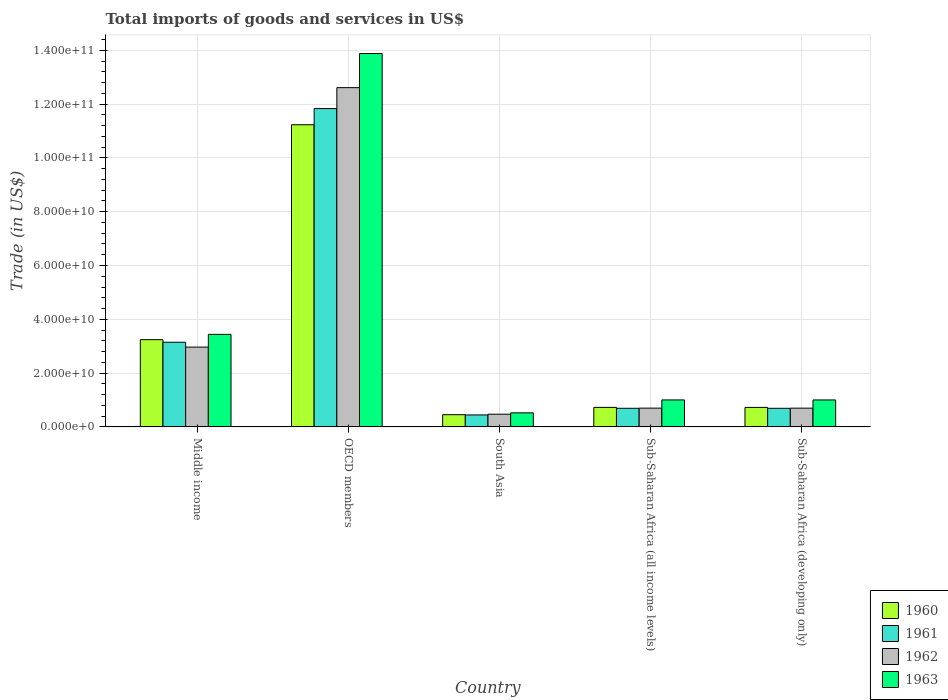How many bars are there on the 2nd tick from the left?
Keep it short and to the point. 4. What is the label of the 2nd group of bars from the left?
Provide a short and direct response. OECD members. In how many cases, is the number of bars for a given country not equal to the number of legend labels?
Your response must be concise. 0. What is the total imports of goods and services in 1963 in Middle income?
Give a very brief answer. 3.44e+1. Across all countries, what is the maximum total imports of goods and services in 1963?
Make the answer very short. 1.39e+11. Across all countries, what is the minimum total imports of goods and services in 1960?
Offer a very short reply. 4.53e+09. What is the total total imports of goods and services in 1963 in the graph?
Your answer should be very brief. 1.98e+11. What is the difference between the total imports of goods and services in 1960 in OECD members and that in South Asia?
Offer a very short reply. 1.08e+11. What is the difference between the total imports of goods and services in 1963 in South Asia and the total imports of goods and services in 1960 in Middle income?
Your response must be concise. -2.72e+1. What is the average total imports of goods and services in 1961 per country?
Provide a short and direct response. 3.36e+1. What is the difference between the total imports of goods and services of/in 1960 and total imports of goods and services of/in 1962 in OECD members?
Your response must be concise. -1.38e+1. What is the ratio of the total imports of goods and services in 1961 in OECD members to that in Sub-Saharan Africa (developing only)?
Provide a short and direct response. 17.14. What is the difference between the highest and the second highest total imports of goods and services in 1961?
Offer a terse response. -8.69e+1. What is the difference between the highest and the lowest total imports of goods and services in 1961?
Make the answer very short. 1.14e+11. Is the sum of the total imports of goods and services in 1960 in OECD members and Sub-Saharan Africa (developing only) greater than the maximum total imports of goods and services in 1961 across all countries?
Your answer should be very brief. Yes. What does the 4th bar from the left in Sub-Saharan Africa (all income levels) represents?
Provide a short and direct response. 1963. Is it the case that in every country, the sum of the total imports of goods and services in 1962 and total imports of goods and services in 1960 is greater than the total imports of goods and services in 1963?
Ensure brevity in your answer.  Yes. How many countries are there in the graph?
Provide a succinct answer. 5. What is the difference between two consecutive major ticks on the Y-axis?
Your answer should be compact. 2.00e+1. Are the values on the major ticks of Y-axis written in scientific E-notation?
Give a very brief answer. Yes. Where does the legend appear in the graph?
Ensure brevity in your answer.  Bottom right. How many legend labels are there?
Provide a short and direct response. 4. What is the title of the graph?
Make the answer very short. Total imports of goods and services in US$. Does "2003" appear as one of the legend labels in the graph?
Provide a short and direct response. No. What is the label or title of the Y-axis?
Your response must be concise. Trade (in US$). What is the Trade (in US$) in 1960 in Middle income?
Give a very brief answer. 3.24e+1. What is the Trade (in US$) in 1961 in Middle income?
Provide a short and direct response. 3.15e+1. What is the Trade (in US$) of 1962 in Middle income?
Offer a very short reply. 2.97e+1. What is the Trade (in US$) in 1963 in Middle income?
Provide a short and direct response. 3.44e+1. What is the Trade (in US$) in 1960 in OECD members?
Your answer should be compact. 1.12e+11. What is the Trade (in US$) of 1961 in OECD members?
Keep it short and to the point. 1.18e+11. What is the Trade (in US$) in 1962 in OECD members?
Offer a terse response. 1.26e+11. What is the Trade (in US$) of 1963 in OECD members?
Ensure brevity in your answer.  1.39e+11. What is the Trade (in US$) in 1960 in South Asia?
Your answer should be compact. 4.53e+09. What is the Trade (in US$) in 1961 in South Asia?
Your response must be concise. 4.43e+09. What is the Trade (in US$) in 1962 in South Asia?
Your answer should be compact. 4.71e+09. What is the Trade (in US$) of 1963 in South Asia?
Offer a terse response. 5.21e+09. What is the Trade (in US$) in 1960 in Sub-Saharan Africa (all income levels)?
Keep it short and to the point. 7.25e+09. What is the Trade (in US$) in 1961 in Sub-Saharan Africa (all income levels)?
Provide a short and direct response. 6.91e+09. What is the Trade (in US$) in 1962 in Sub-Saharan Africa (all income levels)?
Keep it short and to the point. 6.97e+09. What is the Trade (in US$) of 1963 in Sub-Saharan Africa (all income levels)?
Offer a very short reply. 1.00e+1. What is the Trade (in US$) of 1960 in Sub-Saharan Africa (developing only)?
Offer a very short reply. 7.24e+09. What is the Trade (in US$) of 1961 in Sub-Saharan Africa (developing only)?
Offer a terse response. 6.90e+09. What is the Trade (in US$) in 1962 in Sub-Saharan Africa (developing only)?
Your answer should be very brief. 6.96e+09. What is the Trade (in US$) in 1963 in Sub-Saharan Africa (developing only)?
Your answer should be very brief. 1.00e+1. Across all countries, what is the maximum Trade (in US$) of 1960?
Your answer should be compact. 1.12e+11. Across all countries, what is the maximum Trade (in US$) in 1961?
Keep it short and to the point. 1.18e+11. Across all countries, what is the maximum Trade (in US$) of 1962?
Your answer should be compact. 1.26e+11. Across all countries, what is the maximum Trade (in US$) of 1963?
Your answer should be very brief. 1.39e+11. Across all countries, what is the minimum Trade (in US$) in 1960?
Provide a succinct answer. 4.53e+09. Across all countries, what is the minimum Trade (in US$) in 1961?
Ensure brevity in your answer.  4.43e+09. Across all countries, what is the minimum Trade (in US$) in 1962?
Ensure brevity in your answer.  4.71e+09. Across all countries, what is the minimum Trade (in US$) in 1963?
Provide a succinct answer. 5.21e+09. What is the total Trade (in US$) of 1960 in the graph?
Offer a terse response. 1.64e+11. What is the total Trade (in US$) in 1961 in the graph?
Your answer should be very brief. 1.68e+11. What is the total Trade (in US$) in 1962 in the graph?
Your answer should be compact. 1.74e+11. What is the total Trade (in US$) in 1963 in the graph?
Keep it short and to the point. 1.98e+11. What is the difference between the Trade (in US$) of 1960 in Middle income and that in OECD members?
Ensure brevity in your answer.  -7.99e+1. What is the difference between the Trade (in US$) in 1961 in Middle income and that in OECD members?
Provide a short and direct response. -8.69e+1. What is the difference between the Trade (in US$) of 1962 in Middle income and that in OECD members?
Provide a short and direct response. -9.65e+1. What is the difference between the Trade (in US$) in 1963 in Middle income and that in OECD members?
Your answer should be compact. -1.04e+11. What is the difference between the Trade (in US$) of 1960 in Middle income and that in South Asia?
Provide a succinct answer. 2.79e+1. What is the difference between the Trade (in US$) of 1961 in Middle income and that in South Asia?
Offer a terse response. 2.70e+1. What is the difference between the Trade (in US$) in 1962 in Middle income and that in South Asia?
Offer a terse response. 2.50e+1. What is the difference between the Trade (in US$) of 1963 in Middle income and that in South Asia?
Make the answer very short. 2.92e+1. What is the difference between the Trade (in US$) of 1960 in Middle income and that in Sub-Saharan Africa (all income levels)?
Make the answer very short. 2.52e+1. What is the difference between the Trade (in US$) in 1961 in Middle income and that in Sub-Saharan Africa (all income levels)?
Your answer should be compact. 2.46e+1. What is the difference between the Trade (in US$) in 1962 in Middle income and that in Sub-Saharan Africa (all income levels)?
Make the answer very short. 2.27e+1. What is the difference between the Trade (in US$) in 1963 in Middle income and that in Sub-Saharan Africa (all income levels)?
Make the answer very short. 2.44e+1. What is the difference between the Trade (in US$) of 1960 in Middle income and that in Sub-Saharan Africa (developing only)?
Offer a very short reply. 2.52e+1. What is the difference between the Trade (in US$) of 1961 in Middle income and that in Sub-Saharan Africa (developing only)?
Your answer should be compact. 2.46e+1. What is the difference between the Trade (in US$) of 1962 in Middle income and that in Sub-Saharan Africa (developing only)?
Offer a very short reply. 2.27e+1. What is the difference between the Trade (in US$) of 1963 in Middle income and that in Sub-Saharan Africa (developing only)?
Your answer should be compact. 2.44e+1. What is the difference between the Trade (in US$) of 1960 in OECD members and that in South Asia?
Keep it short and to the point. 1.08e+11. What is the difference between the Trade (in US$) in 1961 in OECD members and that in South Asia?
Provide a succinct answer. 1.14e+11. What is the difference between the Trade (in US$) in 1962 in OECD members and that in South Asia?
Keep it short and to the point. 1.21e+11. What is the difference between the Trade (in US$) in 1963 in OECD members and that in South Asia?
Ensure brevity in your answer.  1.34e+11. What is the difference between the Trade (in US$) of 1960 in OECD members and that in Sub-Saharan Africa (all income levels)?
Your response must be concise. 1.05e+11. What is the difference between the Trade (in US$) in 1961 in OECD members and that in Sub-Saharan Africa (all income levels)?
Offer a terse response. 1.11e+11. What is the difference between the Trade (in US$) in 1962 in OECD members and that in Sub-Saharan Africa (all income levels)?
Make the answer very short. 1.19e+11. What is the difference between the Trade (in US$) of 1963 in OECD members and that in Sub-Saharan Africa (all income levels)?
Provide a short and direct response. 1.29e+11. What is the difference between the Trade (in US$) in 1960 in OECD members and that in Sub-Saharan Africa (developing only)?
Keep it short and to the point. 1.05e+11. What is the difference between the Trade (in US$) in 1961 in OECD members and that in Sub-Saharan Africa (developing only)?
Make the answer very short. 1.11e+11. What is the difference between the Trade (in US$) in 1962 in OECD members and that in Sub-Saharan Africa (developing only)?
Give a very brief answer. 1.19e+11. What is the difference between the Trade (in US$) in 1963 in OECD members and that in Sub-Saharan Africa (developing only)?
Provide a succinct answer. 1.29e+11. What is the difference between the Trade (in US$) in 1960 in South Asia and that in Sub-Saharan Africa (all income levels)?
Offer a terse response. -2.72e+09. What is the difference between the Trade (in US$) in 1961 in South Asia and that in Sub-Saharan Africa (all income levels)?
Keep it short and to the point. -2.47e+09. What is the difference between the Trade (in US$) in 1962 in South Asia and that in Sub-Saharan Africa (all income levels)?
Offer a terse response. -2.26e+09. What is the difference between the Trade (in US$) in 1963 in South Asia and that in Sub-Saharan Africa (all income levels)?
Give a very brief answer. -4.81e+09. What is the difference between the Trade (in US$) of 1960 in South Asia and that in Sub-Saharan Africa (developing only)?
Your answer should be very brief. -2.71e+09. What is the difference between the Trade (in US$) of 1961 in South Asia and that in Sub-Saharan Africa (developing only)?
Offer a very short reply. -2.47e+09. What is the difference between the Trade (in US$) in 1962 in South Asia and that in Sub-Saharan Africa (developing only)?
Make the answer very short. -2.25e+09. What is the difference between the Trade (in US$) in 1963 in South Asia and that in Sub-Saharan Africa (developing only)?
Make the answer very short. -4.80e+09. What is the difference between the Trade (in US$) in 1960 in Sub-Saharan Africa (all income levels) and that in Sub-Saharan Africa (developing only)?
Offer a very short reply. 6.98e+06. What is the difference between the Trade (in US$) of 1961 in Sub-Saharan Africa (all income levels) and that in Sub-Saharan Africa (developing only)?
Provide a short and direct response. 6.66e+06. What is the difference between the Trade (in US$) in 1962 in Sub-Saharan Africa (all income levels) and that in Sub-Saharan Africa (developing only)?
Keep it short and to the point. 6.72e+06. What is the difference between the Trade (in US$) in 1963 in Sub-Saharan Africa (all income levels) and that in Sub-Saharan Africa (developing only)?
Keep it short and to the point. 5.66e+06. What is the difference between the Trade (in US$) in 1960 in Middle income and the Trade (in US$) in 1961 in OECD members?
Your answer should be compact. -8.59e+1. What is the difference between the Trade (in US$) of 1960 in Middle income and the Trade (in US$) of 1962 in OECD members?
Your answer should be compact. -9.37e+1. What is the difference between the Trade (in US$) of 1960 in Middle income and the Trade (in US$) of 1963 in OECD members?
Provide a succinct answer. -1.06e+11. What is the difference between the Trade (in US$) of 1961 in Middle income and the Trade (in US$) of 1962 in OECD members?
Offer a very short reply. -9.47e+1. What is the difference between the Trade (in US$) in 1961 in Middle income and the Trade (in US$) in 1963 in OECD members?
Offer a terse response. -1.07e+11. What is the difference between the Trade (in US$) in 1962 in Middle income and the Trade (in US$) in 1963 in OECD members?
Offer a very short reply. -1.09e+11. What is the difference between the Trade (in US$) of 1960 in Middle income and the Trade (in US$) of 1961 in South Asia?
Your answer should be compact. 2.80e+1. What is the difference between the Trade (in US$) in 1960 in Middle income and the Trade (in US$) in 1962 in South Asia?
Your answer should be very brief. 2.77e+1. What is the difference between the Trade (in US$) of 1960 in Middle income and the Trade (in US$) of 1963 in South Asia?
Your answer should be very brief. 2.72e+1. What is the difference between the Trade (in US$) in 1961 in Middle income and the Trade (in US$) in 1962 in South Asia?
Make the answer very short. 2.68e+1. What is the difference between the Trade (in US$) in 1961 in Middle income and the Trade (in US$) in 1963 in South Asia?
Offer a very short reply. 2.63e+1. What is the difference between the Trade (in US$) in 1962 in Middle income and the Trade (in US$) in 1963 in South Asia?
Provide a succinct answer. 2.45e+1. What is the difference between the Trade (in US$) in 1960 in Middle income and the Trade (in US$) in 1961 in Sub-Saharan Africa (all income levels)?
Provide a succinct answer. 2.55e+1. What is the difference between the Trade (in US$) of 1960 in Middle income and the Trade (in US$) of 1962 in Sub-Saharan Africa (all income levels)?
Give a very brief answer. 2.55e+1. What is the difference between the Trade (in US$) in 1960 in Middle income and the Trade (in US$) in 1963 in Sub-Saharan Africa (all income levels)?
Your answer should be compact. 2.24e+1. What is the difference between the Trade (in US$) in 1961 in Middle income and the Trade (in US$) in 1962 in Sub-Saharan Africa (all income levels)?
Offer a terse response. 2.45e+1. What is the difference between the Trade (in US$) of 1961 in Middle income and the Trade (in US$) of 1963 in Sub-Saharan Africa (all income levels)?
Provide a short and direct response. 2.14e+1. What is the difference between the Trade (in US$) of 1962 in Middle income and the Trade (in US$) of 1963 in Sub-Saharan Africa (all income levels)?
Provide a succinct answer. 1.96e+1. What is the difference between the Trade (in US$) in 1960 in Middle income and the Trade (in US$) in 1961 in Sub-Saharan Africa (developing only)?
Keep it short and to the point. 2.55e+1. What is the difference between the Trade (in US$) in 1960 in Middle income and the Trade (in US$) in 1962 in Sub-Saharan Africa (developing only)?
Keep it short and to the point. 2.55e+1. What is the difference between the Trade (in US$) of 1960 in Middle income and the Trade (in US$) of 1963 in Sub-Saharan Africa (developing only)?
Provide a succinct answer. 2.24e+1. What is the difference between the Trade (in US$) of 1961 in Middle income and the Trade (in US$) of 1962 in Sub-Saharan Africa (developing only)?
Your answer should be very brief. 2.45e+1. What is the difference between the Trade (in US$) of 1961 in Middle income and the Trade (in US$) of 1963 in Sub-Saharan Africa (developing only)?
Provide a short and direct response. 2.15e+1. What is the difference between the Trade (in US$) in 1962 in Middle income and the Trade (in US$) in 1963 in Sub-Saharan Africa (developing only)?
Make the answer very short. 1.97e+1. What is the difference between the Trade (in US$) of 1960 in OECD members and the Trade (in US$) of 1961 in South Asia?
Your answer should be compact. 1.08e+11. What is the difference between the Trade (in US$) of 1960 in OECD members and the Trade (in US$) of 1962 in South Asia?
Provide a succinct answer. 1.08e+11. What is the difference between the Trade (in US$) in 1960 in OECD members and the Trade (in US$) in 1963 in South Asia?
Keep it short and to the point. 1.07e+11. What is the difference between the Trade (in US$) of 1961 in OECD members and the Trade (in US$) of 1962 in South Asia?
Offer a terse response. 1.14e+11. What is the difference between the Trade (in US$) in 1961 in OECD members and the Trade (in US$) in 1963 in South Asia?
Provide a succinct answer. 1.13e+11. What is the difference between the Trade (in US$) in 1962 in OECD members and the Trade (in US$) in 1963 in South Asia?
Make the answer very short. 1.21e+11. What is the difference between the Trade (in US$) of 1960 in OECD members and the Trade (in US$) of 1961 in Sub-Saharan Africa (all income levels)?
Offer a very short reply. 1.05e+11. What is the difference between the Trade (in US$) of 1960 in OECD members and the Trade (in US$) of 1962 in Sub-Saharan Africa (all income levels)?
Your answer should be very brief. 1.05e+11. What is the difference between the Trade (in US$) of 1960 in OECD members and the Trade (in US$) of 1963 in Sub-Saharan Africa (all income levels)?
Your answer should be compact. 1.02e+11. What is the difference between the Trade (in US$) of 1961 in OECD members and the Trade (in US$) of 1962 in Sub-Saharan Africa (all income levels)?
Ensure brevity in your answer.  1.11e+11. What is the difference between the Trade (in US$) of 1961 in OECD members and the Trade (in US$) of 1963 in Sub-Saharan Africa (all income levels)?
Ensure brevity in your answer.  1.08e+11. What is the difference between the Trade (in US$) of 1962 in OECD members and the Trade (in US$) of 1963 in Sub-Saharan Africa (all income levels)?
Offer a very short reply. 1.16e+11. What is the difference between the Trade (in US$) in 1960 in OECD members and the Trade (in US$) in 1961 in Sub-Saharan Africa (developing only)?
Your answer should be very brief. 1.05e+11. What is the difference between the Trade (in US$) of 1960 in OECD members and the Trade (in US$) of 1962 in Sub-Saharan Africa (developing only)?
Your answer should be compact. 1.05e+11. What is the difference between the Trade (in US$) in 1960 in OECD members and the Trade (in US$) in 1963 in Sub-Saharan Africa (developing only)?
Offer a very short reply. 1.02e+11. What is the difference between the Trade (in US$) in 1961 in OECD members and the Trade (in US$) in 1962 in Sub-Saharan Africa (developing only)?
Provide a short and direct response. 1.11e+11. What is the difference between the Trade (in US$) in 1961 in OECD members and the Trade (in US$) in 1963 in Sub-Saharan Africa (developing only)?
Your answer should be compact. 1.08e+11. What is the difference between the Trade (in US$) of 1962 in OECD members and the Trade (in US$) of 1963 in Sub-Saharan Africa (developing only)?
Offer a terse response. 1.16e+11. What is the difference between the Trade (in US$) in 1960 in South Asia and the Trade (in US$) in 1961 in Sub-Saharan Africa (all income levels)?
Offer a terse response. -2.38e+09. What is the difference between the Trade (in US$) in 1960 in South Asia and the Trade (in US$) in 1962 in Sub-Saharan Africa (all income levels)?
Give a very brief answer. -2.44e+09. What is the difference between the Trade (in US$) of 1960 in South Asia and the Trade (in US$) of 1963 in Sub-Saharan Africa (all income levels)?
Ensure brevity in your answer.  -5.49e+09. What is the difference between the Trade (in US$) of 1961 in South Asia and the Trade (in US$) of 1962 in Sub-Saharan Africa (all income levels)?
Keep it short and to the point. -2.53e+09. What is the difference between the Trade (in US$) in 1961 in South Asia and the Trade (in US$) in 1963 in Sub-Saharan Africa (all income levels)?
Your response must be concise. -5.58e+09. What is the difference between the Trade (in US$) in 1962 in South Asia and the Trade (in US$) in 1963 in Sub-Saharan Africa (all income levels)?
Ensure brevity in your answer.  -5.31e+09. What is the difference between the Trade (in US$) in 1960 in South Asia and the Trade (in US$) in 1961 in Sub-Saharan Africa (developing only)?
Keep it short and to the point. -2.38e+09. What is the difference between the Trade (in US$) of 1960 in South Asia and the Trade (in US$) of 1962 in Sub-Saharan Africa (developing only)?
Your response must be concise. -2.43e+09. What is the difference between the Trade (in US$) in 1960 in South Asia and the Trade (in US$) in 1963 in Sub-Saharan Africa (developing only)?
Offer a very short reply. -5.48e+09. What is the difference between the Trade (in US$) of 1961 in South Asia and the Trade (in US$) of 1962 in Sub-Saharan Africa (developing only)?
Ensure brevity in your answer.  -2.53e+09. What is the difference between the Trade (in US$) in 1961 in South Asia and the Trade (in US$) in 1963 in Sub-Saharan Africa (developing only)?
Make the answer very short. -5.58e+09. What is the difference between the Trade (in US$) of 1962 in South Asia and the Trade (in US$) of 1963 in Sub-Saharan Africa (developing only)?
Your answer should be compact. -5.30e+09. What is the difference between the Trade (in US$) of 1960 in Sub-Saharan Africa (all income levels) and the Trade (in US$) of 1961 in Sub-Saharan Africa (developing only)?
Your answer should be very brief. 3.42e+08. What is the difference between the Trade (in US$) of 1960 in Sub-Saharan Africa (all income levels) and the Trade (in US$) of 1962 in Sub-Saharan Africa (developing only)?
Give a very brief answer. 2.84e+08. What is the difference between the Trade (in US$) in 1960 in Sub-Saharan Africa (all income levels) and the Trade (in US$) in 1963 in Sub-Saharan Africa (developing only)?
Provide a short and direct response. -2.77e+09. What is the difference between the Trade (in US$) in 1961 in Sub-Saharan Africa (all income levels) and the Trade (in US$) in 1962 in Sub-Saharan Africa (developing only)?
Keep it short and to the point. -5.13e+07. What is the difference between the Trade (in US$) of 1961 in Sub-Saharan Africa (all income levels) and the Trade (in US$) of 1963 in Sub-Saharan Africa (developing only)?
Provide a short and direct response. -3.10e+09. What is the difference between the Trade (in US$) of 1962 in Sub-Saharan Africa (all income levels) and the Trade (in US$) of 1963 in Sub-Saharan Africa (developing only)?
Your response must be concise. -3.04e+09. What is the average Trade (in US$) of 1960 per country?
Ensure brevity in your answer.  3.28e+1. What is the average Trade (in US$) of 1961 per country?
Your answer should be very brief. 3.36e+1. What is the average Trade (in US$) in 1962 per country?
Your answer should be very brief. 3.49e+1. What is the average Trade (in US$) of 1963 per country?
Give a very brief answer. 3.97e+1. What is the difference between the Trade (in US$) of 1960 and Trade (in US$) of 1961 in Middle income?
Your answer should be very brief. 9.57e+08. What is the difference between the Trade (in US$) of 1960 and Trade (in US$) of 1962 in Middle income?
Your answer should be very brief. 2.76e+09. What is the difference between the Trade (in US$) in 1960 and Trade (in US$) in 1963 in Middle income?
Provide a short and direct response. -1.97e+09. What is the difference between the Trade (in US$) in 1961 and Trade (in US$) in 1962 in Middle income?
Provide a short and direct response. 1.80e+09. What is the difference between the Trade (in US$) in 1961 and Trade (in US$) in 1963 in Middle income?
Your answer should be very brief. -2.93e+09. What is the difference between the Trade (in US$) in 1962 and Trade (in US$) in 1963 in Middle income?
Your response must be concise. -4.73e+09. What is the difference between the Trade (in US$) of 1960 and Trade (in US$) of 1961 in OECD members?
Provide a short and direct response. -6.01e+09. What is the difference between the Trade (in US$) of 1960 and Trade (in US$) of 1962 in OECD members?
Provide a succinct answer. -1.38e+1. What is the difference between the Trade (in US$) of 1960 and Trade (in US$) of 1963 in OECD members?
Ensure brevity in your answer.  -2.65e+1. What is the difference between the Trade (in US$) of 1961 and Trade (in US$) of 1962 in OECD members?
Provide a succinct answer. -7.79e+09. What is the difference between the Trade (in US$) in 1961 and Trade (in US$) in 1963 in OECD members?
Give a very brief answer. -2.05e+1. What is the difference between the Trade (in US$) of 1962 and Trade (in US$) of 1963 in OECD members?
Your answer should be very brief. -1.27e+1. What is the difference between the Trade (in US$) of 1960 and Trade (in US$) of 1961 in South Asia?
Your response must be concise. 9.31e+07. What is the difference between the Trade (in US$) in 1960 and Trade (in US$) in 1962 in South Asia?
Your answer should be very brief. -1.84e+08. What is the difference between the Trade (in US$) in 1960 and Trade (in US$) in 1963 in South Asia?
Your answer should be very brief. -6.84e+08. What is the difference between the Trade (in US$) in 1961 and Trade (in US$) in 1962 in South Asia?
Ensure brevity in your answer.  -2.77e+08. What is the difference between the Trade (in US$) of 1961 and Trade (in US$) of 1963 in South Asia?
Ensure brevity in your answer.  -7.77e+08. What is the difference between the Trade (in US$) of 1962 and Trade (in US$) of 1963 in South Asia?
Offer a terse response. -5.00e+08. What is the difference between the Trade (in US$) of 1960 and Trade (in US$) of 1961 in Sub-Saharan Africa (all income levels)?
Give a very brief answer. 3.36e+08. What is the difference between the Trade (in US$) in 1960 and Trade (in US$) in 1962 in Sub-Saharan Africa (all income levels)?
Make the answer very short. 2.78e+08. What is the difference between the Trade (in US$) in 1960 and Trade (in US$) in 1963 in Sub-Saharan Africa (all income levels)?
Your answer should be very brief. -2.77e+09. What is the difference between the Trade (in US$) of 1961 and Trade (in US$) of 1962 in Sub-Saharan Africa (all income levels)?
Provide a short and direct response. -5.80e+07. What is the difference between the Trade (in US$) of 1961 and Trade (in US$) of 1963 in Sub-Saharan Africa (all income levels)?
Offer a very short reply. -3.11e+09. What is the difference between the Trade (in US$) of 1962 and Trade (in US$) of 1963 in Sub-Saharan Africa (all income levels)?
Provide a short and direct response. -3.05e+09. What is the difference between the Trade (in US$) in 1960 and Trade (in US$) in 1961 in Sub-Saharan Africa (developing only)?
Your answer should be very brief. 3.35e+08. What is the difference between the Trade (in US$) in 1960 and Trade (in US$) in 1962 in Sub-Saharan Africa (developing only)?
Your answer should be compact. 2.77e+08. What is the difference between the Trade (in US$) in 1960 and Trade (in US$) in 1963 in Sub-Saharan Africa (developing only)?
Make the answer very short. -2.77e+09. What is the difference between the Trade (in US$) in 1961 and Trade (in US$) in 1962 in Sub-Saharan Africa (developing only)?
Ensure brevity in your answer.  -5.79e+07. What is the difference between the Trade (in US$) in 1961 and Trade (in US$) in 1963 in Sub-Saharan Africa (developing only)?
Make the answer very short. -3.11e+09. What is the difference between the Trade (in US$) in 1962 and Trade (in US$) in 1963 in Sub-Saharan Africa (developing only)?
Provide a succinct answer. -3.05e+09. What is the ratio of the Trade (in US$) of 1960 in Middle income to that in OECD members?
Provide a short and direct response. 0.29. What is the ratio of the Trade (in US$) in 1961 in Middle income to that in OECD members?
Provide a short and direct response. 0.27. What is the ratio of the Trade (in US$) of 1962 in Middle income to that in OECD members?
Your response must be concise. 0.24. What is the ratio of the Trade (in US$) of 1963 in Middle income to that in OECD members?
Ensure brevity in your answer.  0.25. What is the ratio of the Trade (in US$) of 1960 in Middle income to that in South Asia?
Provide a succinct answer. 7.16. What is the ratio of the Trade (in US$) of 1961 in Middle income to that in South Asia?
Offer a very short reply. 7.1. What is the ratio of the Trade (in US$) of 1962 in Middle income to that in South Asia?
Provide a short and direct response. 6.3. What is the ratio of the Trade (in US$) of 1963 in Middle income to that in South Asia?
Provide a short and direct response. 6.6. What is the ratio of the Trade (in US$) of 1960 in Middle income to that in Sub-Saharan Africa (all income levels)?
Provide a short and direct response. 4.47. What is the ratio of the Trade (in US$) in 1961 in Middle income to that in Sub-Saharan Africa (all income levels)?
Your answer should be very brief. 4.55. What is the ratio of the Trade (in US$) in 1962 in Middle income to that in Sub-Saharan Africa (all income levels)?
Provide a succinct answer. 4.26. What is the ratio of the Trade (in US$) of 1963 in Middle income to that in Sub-Saharan Africa (all income levels)?
Offer a very short reply. 3.43. What is the ratio of the Trade (in US$) in 1960 in Middle income to that in Sub-Saharan Africa (developing only)?
Your answer should be compact. 4.48. What is the ratio of the Trade (in US$) of 1961 in Middle income to that in Sub-Saharan Africa (developing only)?
Provide a succinct answer. 4.56. What is the ratio of the Trade (in US$) of 1962 in Middle income to that in Sub-Saharan Africa (developing only)?
Your answer should be compact. 4.26. What is the ratio of the Trade (in US$) of 1963 in Middle income to that in Sub-Saharan Africa (developing only)?
Your response must be concise. 3.44. What is the ratio of the Trade (in US$) in 1960 in OECD members to that in South Asia?
Give a very brief answer. 24.81. What is the ratio of the Trade (in US$) of 1961 in OECD members to that in South Asia?
Offer a terse response. 26.69. What is the ratio of the Trade (in US$) of 1962 in OECD members to that in South Asia?
Your answer should be very brief. 26.77. What is the ratio of the Trade (in US$) in 1963 in OECD members to that in South Asia?
Your answer should be compact. 26.63. What is the ratio of the Trade (in US$) in 1960 in OECD members to that in Sub-Saharan Africa (all income levels)?
Your answer should be compact. 15.5. What is the ratio of the Trade (in US$) in 1961 in OECD members to that in Sub-Saharan Africa (all income levels)?
Ensure brevity in your answer.  17.13. What is the ratio of the Trade (in US$) of 1962 in OECD members to that in Sub-Saharan Africa (all income levels)?
Make the answer very short. 18.1. What is the ratio of the Trade (in US$) of 1963 in OECD members to that in Sub-Saharan Africa (all income levels)?
Provide a short and direct response. 13.86. What is the ratio of the Trade (in US$) in 1960 in OECD members to that in Sub-Saharan Africa (developing only)?
Offer a terse response. 15.52. What is the ratio of the Trade (in US$) of 1961 in OECD members to that in Sub-Saharan Africa (developing only)?
Your answer should be very brief. 17.14. What is the ratio of the Trade (in US$) in 1962 in OECD members to that in Sub-Saharan Africa (developing only)?
Provide a short and direct response. 18.12. What is the ratio of the Trade (in US$) in 1963 in OECD members to that in Sub-Saharan Africa (developing only)?
Ensure brevity in your answer.  13.86. What is the ratio of the Trade (in US$) of 1960 in South Asia to that in Sub-Saharan Africa (all income levels)?
Your response must be concise. 0.62. What is the ratio of the Trade (in US$) in 1961 in South Asia to that in Sub-Saharan Africa (all income levels)?
Your answer should be compact. 0.64. What is the ratio of the Trade (in US$) in 1962 in South Asia to that in Sub-Saharan Africa (all income levels)?
Provide a succinct answer. 0.68. What is the ratio of the Trade (in US$) of 1963 in South Asia to that in Sub-Saharan Africa (all income levels)?
Offer a very short reply. 0.52. What is the ratio of the Trade (in US$) of 1960 in South Asia to that in Sub-Saharan Africa (developing only)?
Offer a terse response. 0.63. What is the ratio of the Trade (in US$) of 1961 in South Asia to that in Sub-Saharan Africa (developing only)?
Make the answer very short. 0.64. What is the ratio of the Trade (in US$) in 1962 in South Asia to that in Sub-Saharan Africa (developing only)?
Your answer should be compact. 0.68. What is the ratio of the Trade (in US$) of 1963 in South Asia to that in Sub-Saharan Africa (developing only)?
Provide a succinct answer. 0.52. What is the ratio of the Trade (in US$) in 1961 in Sub-Saharan Africa (all income levels) to that in Sub-Saharan Africa (developing only)?
Make the answer very short. 1. What is the ratio of the Trade (in US$) of 1962 in Sub-Saharan Africa (all income levels) to that in Sub-Saharan Africa (developing only)?
Your response must be concise. 1. What is the ratio of the Trade (in US$) of 1963 in Sub-Saharan Africa (all income levels) to that in Sub-Saharan Africa (developing only)?
Your answer should be compact. 1. What is the difference between the highest and the second highest Trade (in US$) in 1960?
Your answer should be compact. 7.99e+1. What is the difference between the highest and the second highest Trade (in US$) of 1961?
Your answer should be very brief. 8.69e+1. What is the difference between the highest and the second highest Trade (in US$) of 1962?
Offer a terse response. 9.65e+1. What is the difference between the highest and the second highest Trade (in US$) in 1963?
Provide a short and direct response. 1.04e+11. What is the difference between the highest and the lowest Trade (in US$) of 1960?
Ensure brevity in your answer.  1.08e+11. What is the difference between the highest and the lowest Trade (in US$) of 1961?
Offer a very short reply. 1.14e+11. What is the difference between the highest and the lowest Trade (in US$) of 1962?
Provide a short and direct response. 1.21e+11. What is the difference between the highest and the lowest Trade (in US$) in 1963?
Make the answer very short. 1.34e+11. 